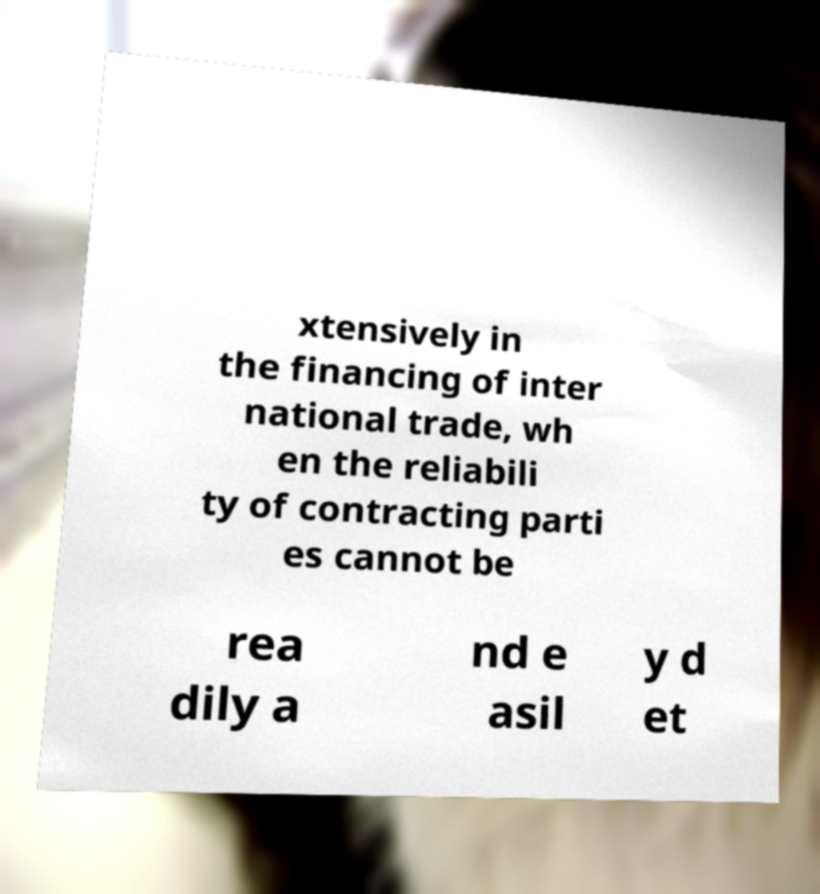I need the written content from this picture converted into text. Can you do that? xtensively in the financing of inter national trade, wh en the reliabili ty of contracting parti es cannot be rea dily a nd e asil y d et 